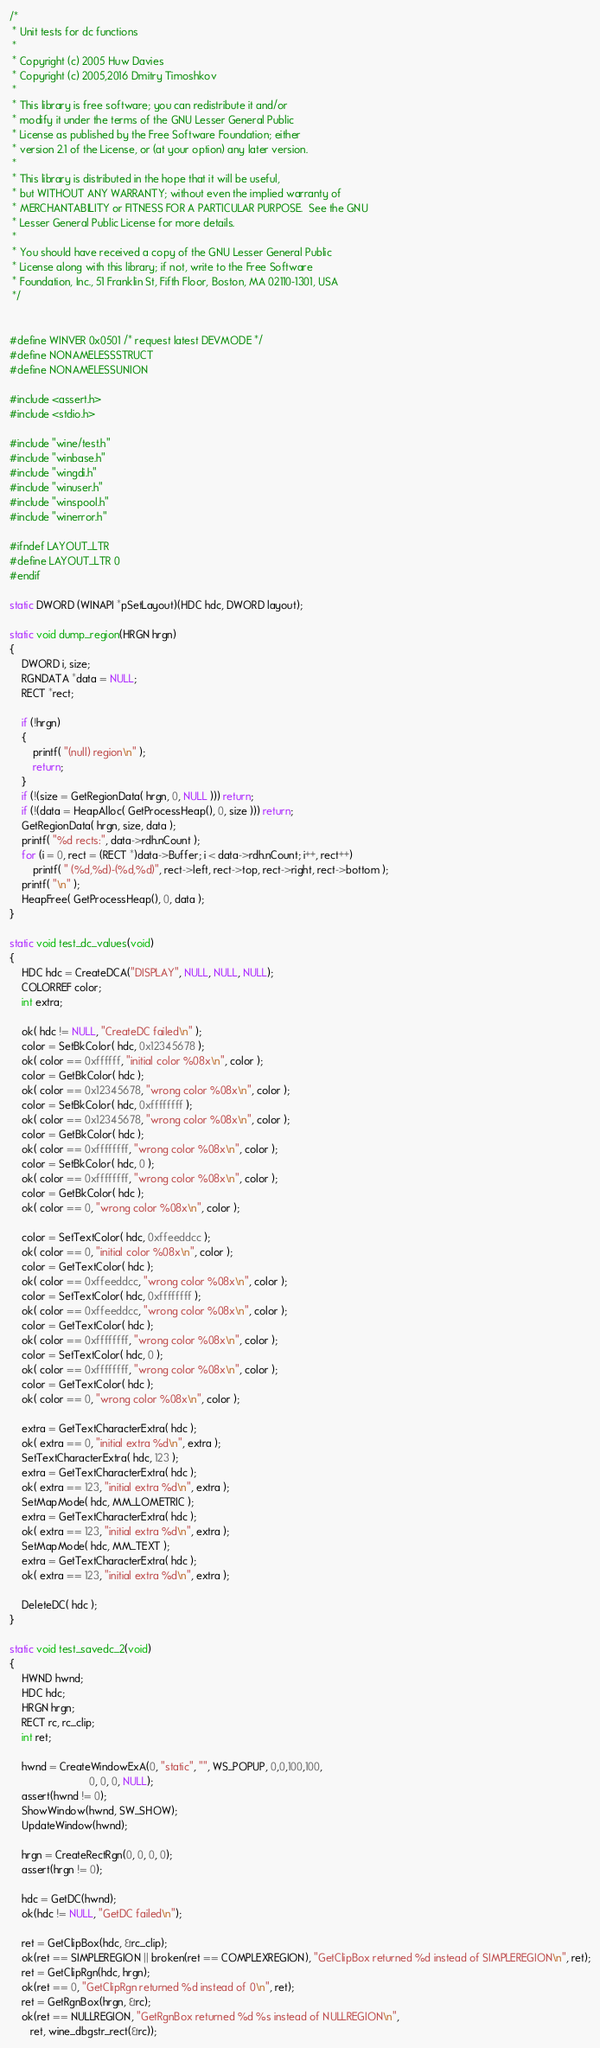<code> <loc_0><loc_0><loc_500><loc_500><_C_>/*
 * Unit tests for dc functions
 *
 * Copyright (c) 2005 Huw Davies
 * Copyright (c) 2005,2016 Dmitry Timoshkov
 *
 * This library is free software; you can redistribute it and/or
 * modify it under the terms of the GNU Lesser General Public
 * License as published by the Free Software Foundation; either
 * version 2.1 of the License, or (at your option) any later version.
 *
 * This library is distributed in the hope that it will be useful,
 * but WITHOUT ANY WARRANTY; without even the implied warranty of
 * MERCHANTABILITY or FITNESS FOR A PARTICULAR PURPOSE.  See the GNU
 * Lesser General Public License for more details.
 *
 * You should have received a copy of the GNU Lesser General Public
 * License along with this library; if not, write to the Free Software
 * Foundation, Inc., 51 Franklin St, Fifth Floor, Boston, MA 02110-1301, USA
 */


#define WINVER 0x0501 /* request latest DEVMODE */
#define NONAMELESSSTRUCT
#define NONAMELESSUNION

#include <assert.h>
#include <stdio.h>

#include "wine/test.h"
#include "winbase.h"
#include "wingdi.h"
#include "winuser.h"
#include "winspool.h"
#include "winerror.h"

#ifndef LAYOUT_LTR
#define LAYOUT_LTR 0
#endif

static DWORD (WINAPI *pSetLayout)(HDC hdc, DWORD layout);

static void dump_region(HRGN hrgn)
{
    DWORD i, size;
    RGNDATA *data = NULL;
    RECT *rect;

    if (!hrgn)
    {
        printf( "(null) region\n" );
        return;
    }
    if (!(size = GetRegionData( hrgn, 0, NULL ))) return;
    if (!(data = HeapAlloc( GetProcessHeap(), 0, size ))) return;
    GetRegionData( hrgn, size, data );
    printf( "%d rects:", data->rdh.nCount );
    for (i = 0, rect = (RECT *)data->Buffer; i < data->rdh.nCount; i++, rect++)
        printf( " (%d,%d)-(%d,%d)", rect->left, rect->top, rect->right, rect->bottom );
    printf( "\n" );
    HeapFree( GetProcessHeap(), 0, data );
}

static void test_dc_values(void)
{
    HDC hdc = CreateDCA("DISPLAY", NULL, NULL, NULL);
    COLORREF color;
    int extra;

    ok( hdc != NULL, "CreateDC failed\n" );
    color = SetBkColor( hdc, 0x12345678 );
    ok( color == 0xffffff, "initial color %08x\n", color );
    color = GetBkColor( hdc );
    ok( color == 0x12345678, "wrong color %08x\n", color );
    color = SetBkColor( hdc, 0xffffffff );
    ok( color == 0x12345678, "wrong color %08x\n", color );
    color = GetBkColor( hdc );
    ok( color == 0xffffffff, "wrong color %08x\n", color );
    color = SetBkColor( hdc, 0 );
    ok( color == 0xffffffff, "wrong color %08x\n", color );
    color = GetBkColor( hdc );
    ok( color == 0, "wrong color %08x\n", color );

    color = SetTextColor( hdc, 0xffeeddcc );
    ok( color == 0, "initial color %08x\n", color );
    color = GetTextColor( hdc );
    ok( color == 0xffeeddcc, "wrong color %08x\n", color );
    color = SetTextColor( hdc, 0xffffffff );
    ok( color == 0xffeeddcc, "wrong color %08x\n", color );
    color = GetTextColor( hdc );
    ok( color == 0xffffffff, "wrong color %08x\n", color );
    color = SetTextColor( hdc, 0 );
    ok( color == 0xffffffff, "wrong color %08x\n", color );
    color = GetTextColor( hdc );
    ok( color == 0, "wrong color %08x\n", color );

    extra = GetTextCharacterExtra( hdc );
    ok( extra == 0, "initial extra %d\n", extra );
    SetTextCharacterExtra( hdc, 123 );
    extra = GetTextCharacterExtra( hdc );
    ok( extra == 123, "initial extra %d\n", extra );
    SetMapMode( hdc, MM_LOMETRIC );
    extra = GetTextCharacterExtra( hdc );
    ok( extra == 123, "initial extra %d\n", extra );
    SetMapMode( hdc, MM_TEXT );
    extra = GetTextCharacterExtra( hdc );
    ok( extra == 123, "initial extra %d\n", extra );

    DeleteDC( hdc );
}

static void test_savedc_2(void)
{
    HWND hwnd;
    HDC hdc;
    HRGN hrgn;
    RECT rc, rc_clip;
    int ret;

    hwnd = CreateWindowExA(0, "static", "", WS_POPUP, 0,0,100,100,
                           0, 0, 0, NULL);
    assert(hwnd != 0);
    ShowWindow(hwnd, SW_SHOW);
    UpdateWindow(hwnd);

    hrgn = CreateRectRgn(0, 0, 0, 0);
    assert(hrgn != 0);

    hdc = GetDC(hwnd);
    ok(hdc != NULL, "GetDC failed\n");

    ret = GetClipBox(hdc, &rc_clip);
    ok(ret == SIMPLEREGION || broken(ret == COMPLEXREGION), "GetClipBox returned %d instead of SIMPLEREGION\n", ret);
    ret = GetClipRgn(hdc, hrgn);
    ok(ret == 0, "GetClipRgn returned %d instead of 0\n", ret);
    ret = GetRgnBox(hrgn, &rc);
    ok(ret == NULLREGION, "GetRgnBox returned %d %s instead of NULLREGION\n",
       ret, wine_dbgstr_rect(&rc));</code> 